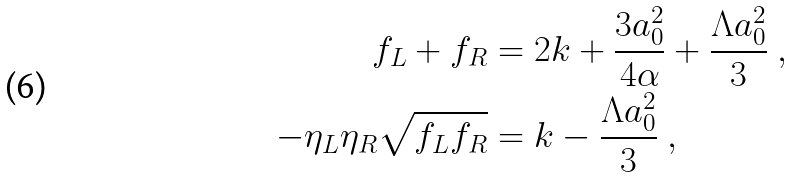Convert formula to latex. <formula><loc_0><loc_0><loc_500><loc_500>f _ { L } + f _ { R } & = 2 k + \frac { 3 a _ { 0 } ^ { 2 } } { 4 \alpha } + \frac { \Lambda a _ { 0 } ^ { 2 } } { 3 } \ , \\ - \eta _ { L } \eta _ { R } \sqrt { f _ { L } f _ { R } } & = k - \frac { \Lambda a _ { 0 } ^ { 2 } } { 3 } \ ,</formula> 